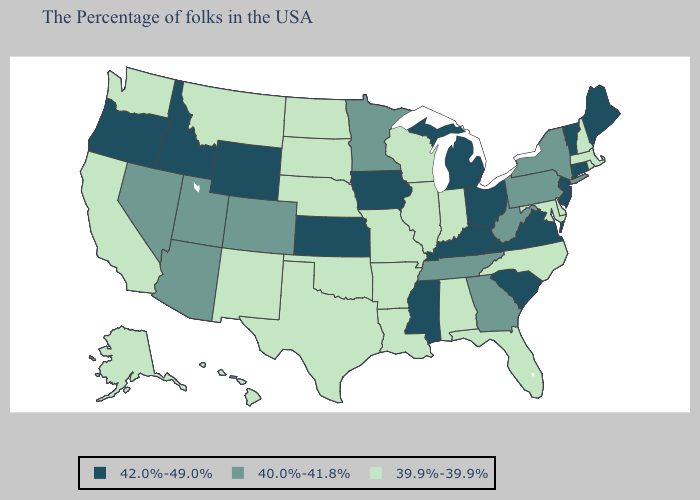Name the states that have a value in the range 40.0%-41.8%?
Answer briefly. New York, Pennsylvania, West Virginia, Georgia, Tennessee, Minnesota, Colorado, Utah, Arizona, Nevada. Does Nevada have the lowest value in the USA?
Answer briefly. No. What is the value of Alabama?
Short answer required. 39.9%-39.9%. What is the lowest value in the MidWest?
Quick response, please. 39.9%-39.9%. Does the map have missing data?
Answer briefly. No. Does the map have missing data?
Concise answer only. No. Name the states that have a value in the range 40.0%-41.8%?
Answer briefly. New York, Pennsylvania, West Virginia, Georgia, Tennessee, Minnesota, Colorado, Utah, Arizona, Nevada. Name the states that have a value in the range 40.0%-41.8%?
Keep it brief. New York, Pennsylvania, West Virginia, Georgia, Tennessee, Minnesota, Colorado, Utah, Arizona, Nevada. Which states hav the highest value in the MidWest?
Quick response, please. Ohio, Michigan, Iowa, Kansas. Which states have the lowest value in the USA?
Concise answer only. Massachusetts, Rhode Island, New Hampshire, Delaware, Maryland, North Carolina, Florida, Indiana, Alabama, Wisconsin, Illinois, Louisiana, Missouri, Arkansas, Nebraska, Oklahoma, Texas, South Dakota, North Dakota, New Mexico, Montana, California, Washington, Alaska, Hawaii. What is the value of Arkansas?
Quick response, please. 39.9%-39.9%. What is the lowest value in states that border New York?
Give a very brief answer. 39.9%-39.9%. Name the states that have a value in the range 39.9%-39.9%?
Short answer required. Massachusetts, Rhode Island, New Hampshire, Delaware, Maryland, North Carolina, Florida, Indiana, Alabama, Wisconsin, Illinois, Louisiana, Missouri, Arkansas, Nebraska, Oklahoma, Texas, South Dakota, North Dakota, New Mexico, Montana, California, Washington, Alaska, Hawaii. What is the value of New York?
Be succinct. 40.0%-41.8%. 